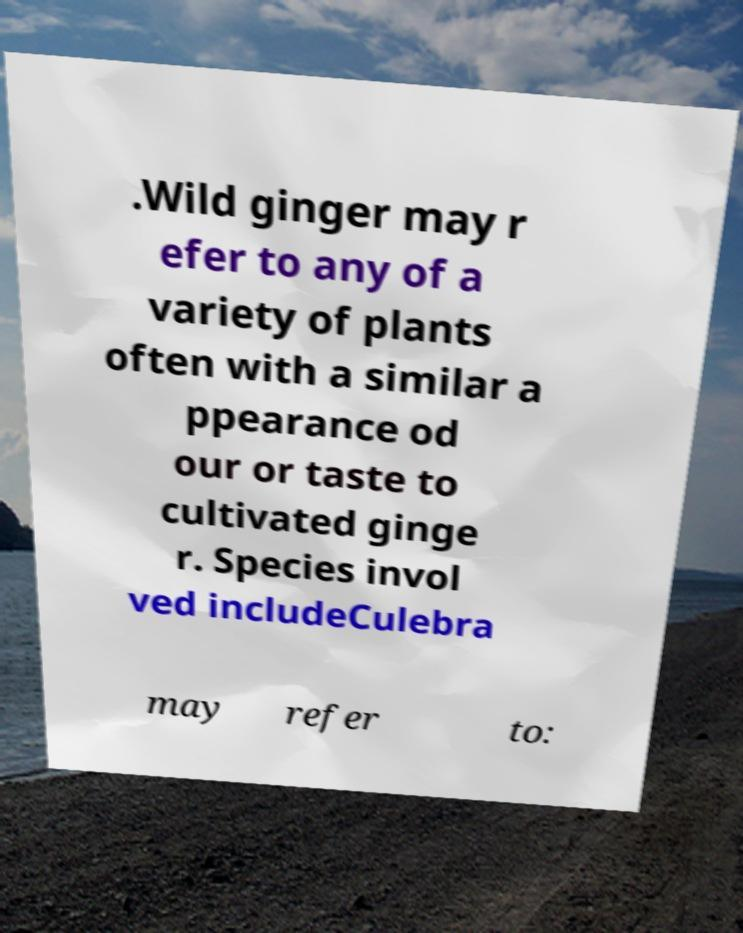Please read and relay the text visible in this image. What does it say? .Wild ginger may r efer to any of a variety of plants often with a similar a ppearance od our or taste to cultivated ginge r. Species invol ved includeCulebra may refer to: 